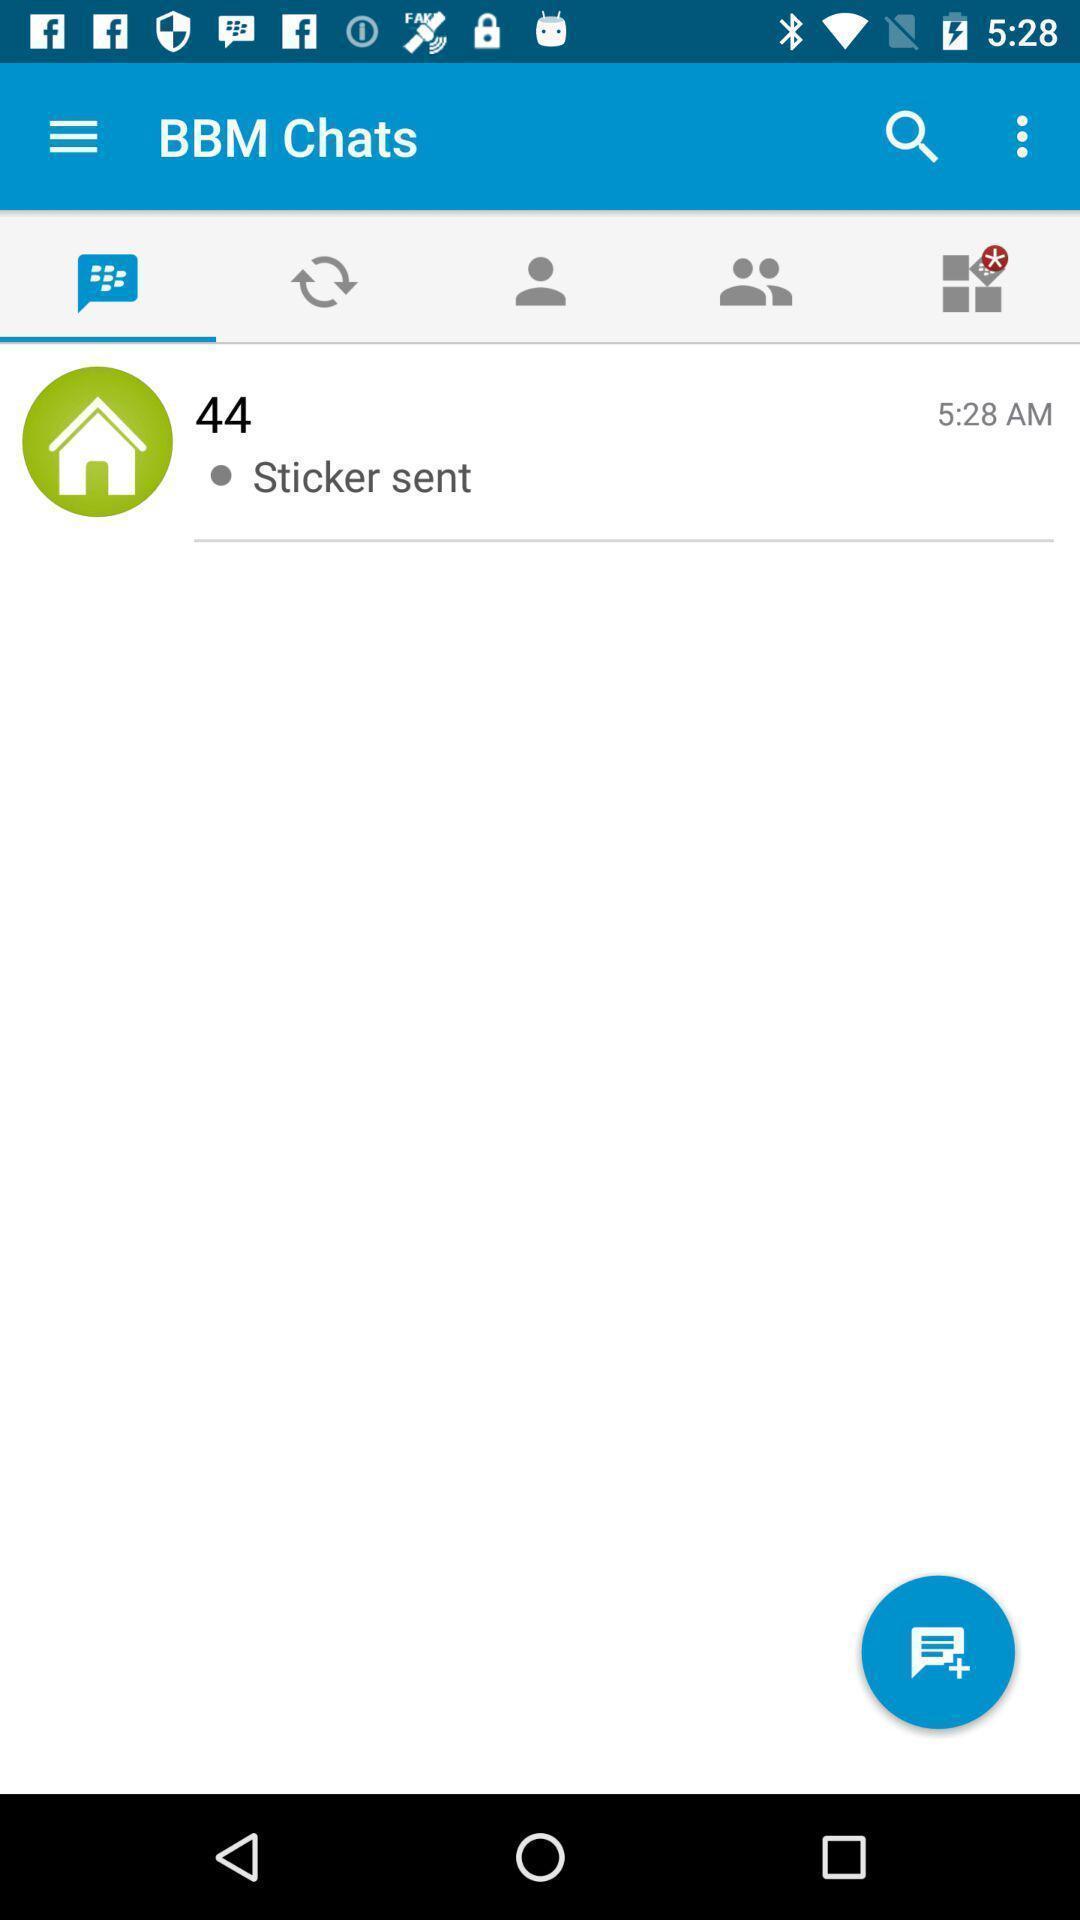What details can you identify in this image? Page for sending new messages of a messaging app. 